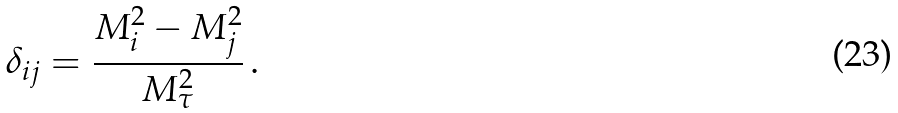<formula> <loc_0><loc_0><loc_500><loc_500>\delta _ { i j } = \frac { M _ { i } ^ { 2 } - M _ { j } ^ { 2 } } { M _ { \tau } ^ { 2 } } \, .</formula> 